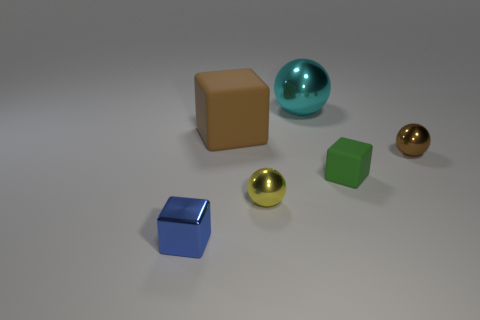What is the shape of the large matte object?
Your answer should be very brief. Cube. What number of objects are either big cyan metallic objects or matte objects that are on the left side of the cyan metallic object?
Ensure brevity in your answer.  2. Is the color of the small sphere that is on the right side of the green cube the same as the small metallic cube?
Offer a terse response. No. The tiny thing that is in front of the small green cube and right of the metallic block is what color?
Ensure brevity in your answer.  Yellow. There is a brown object that is left of the yellow metallic object; what material is it?
Keep it short and to the point. Rubber. What size is the brown rubber object?
Keep it short and to the point. Large. How many gray objects are metallic balls or shiny cylinders?
Keep it short and to the point. 0. There is a brown object on the right side of the sphere behind the brown metal ball; what is its size?
Make the answer very short. Small. There is a tiny rubber thing; does it have the same color as the thing behind the brown block?
Your answer should be very brief. No. How many other objects are the same material as the large cyan ball?
Your answer should be compact. 3. 